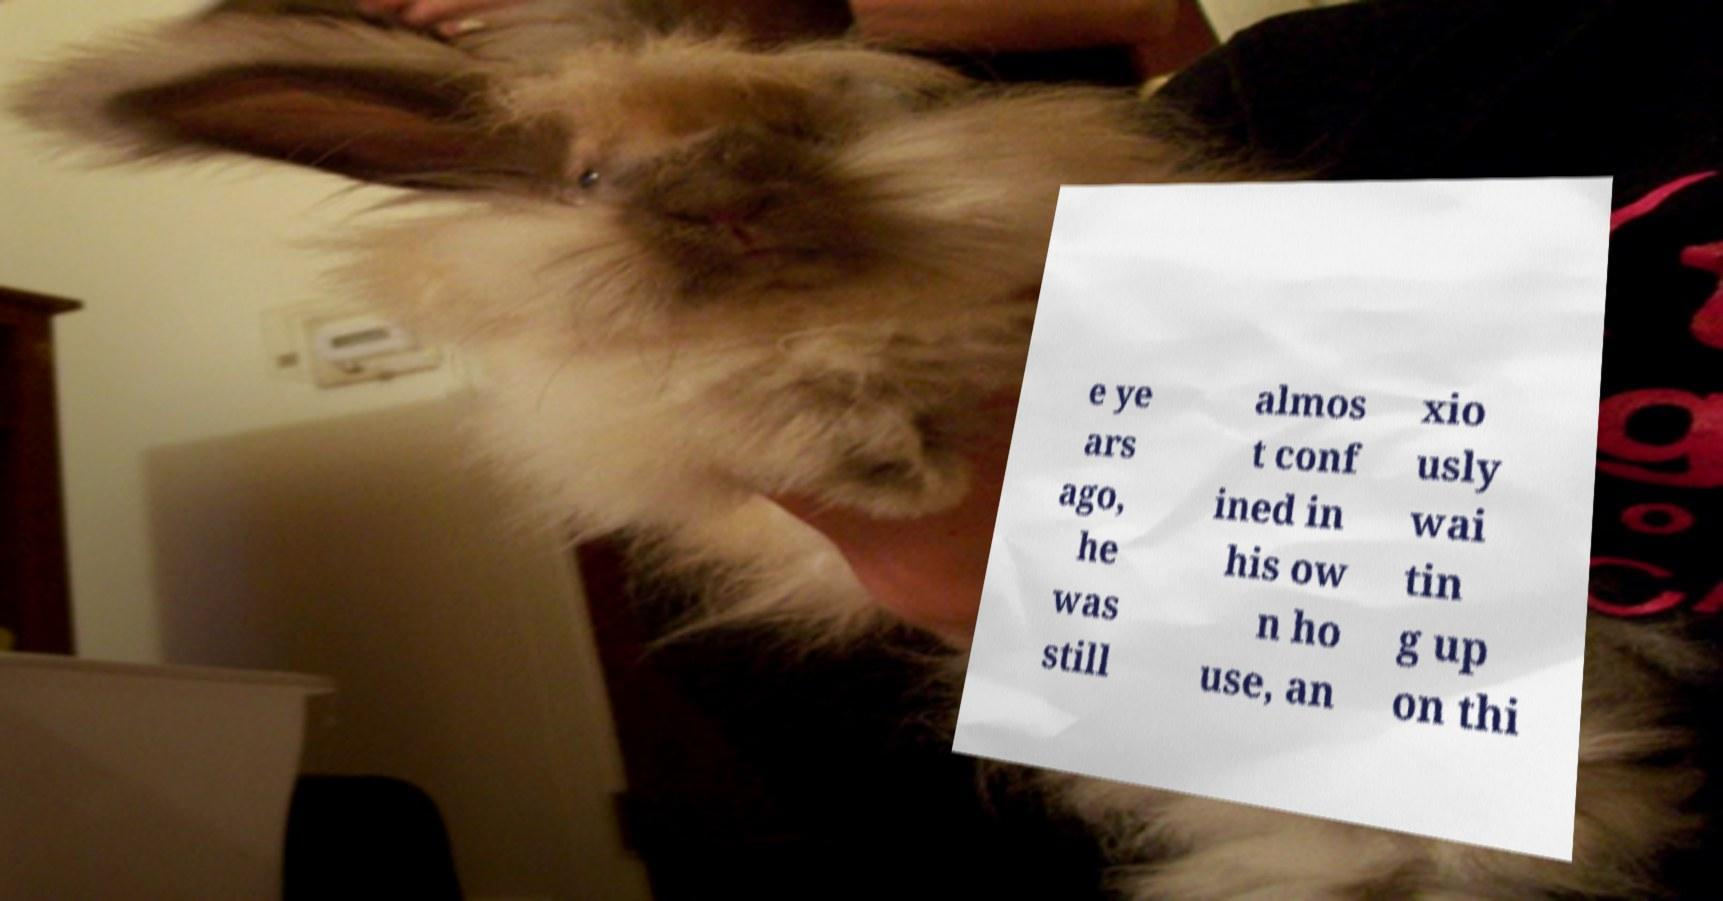Please read and relay the text visible in this image. What does it say? e ye ars ago, he was still almos t conf ined in his ow n ho use, an xio usly wai tin g up on thi 